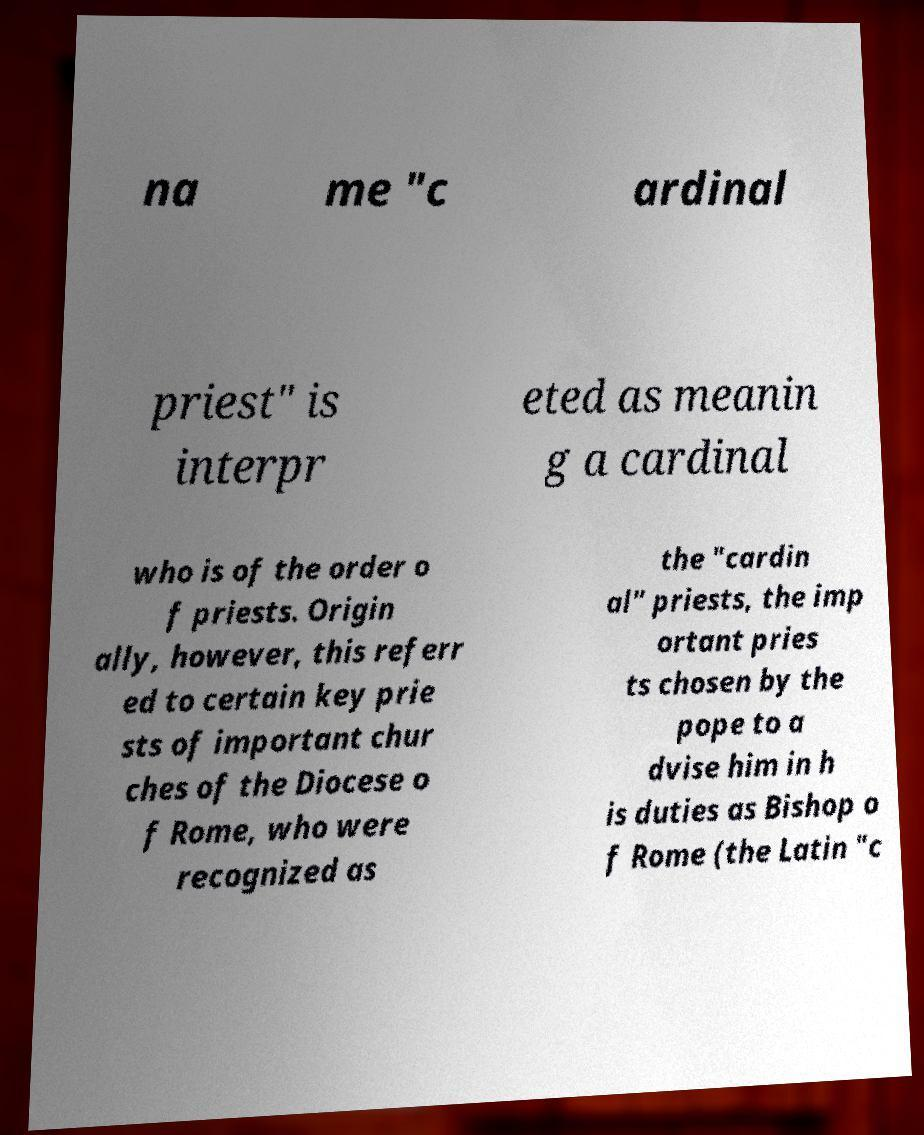Could you assist in decoding the text presented in this image and type it out clearly? na me "c ardinal priest" is interpr eted as meanin g a cardinal who is of the order o f priests. Origin ally, however, this referr ed to certain key prie sts of important chur ches of the Diocese o f Rome, who were recognized as the "cardin al" priests, the imp ortant pries ts chosen by the pope to a dvise him in h is duties as Bishop o f Rome (the Latin "c 